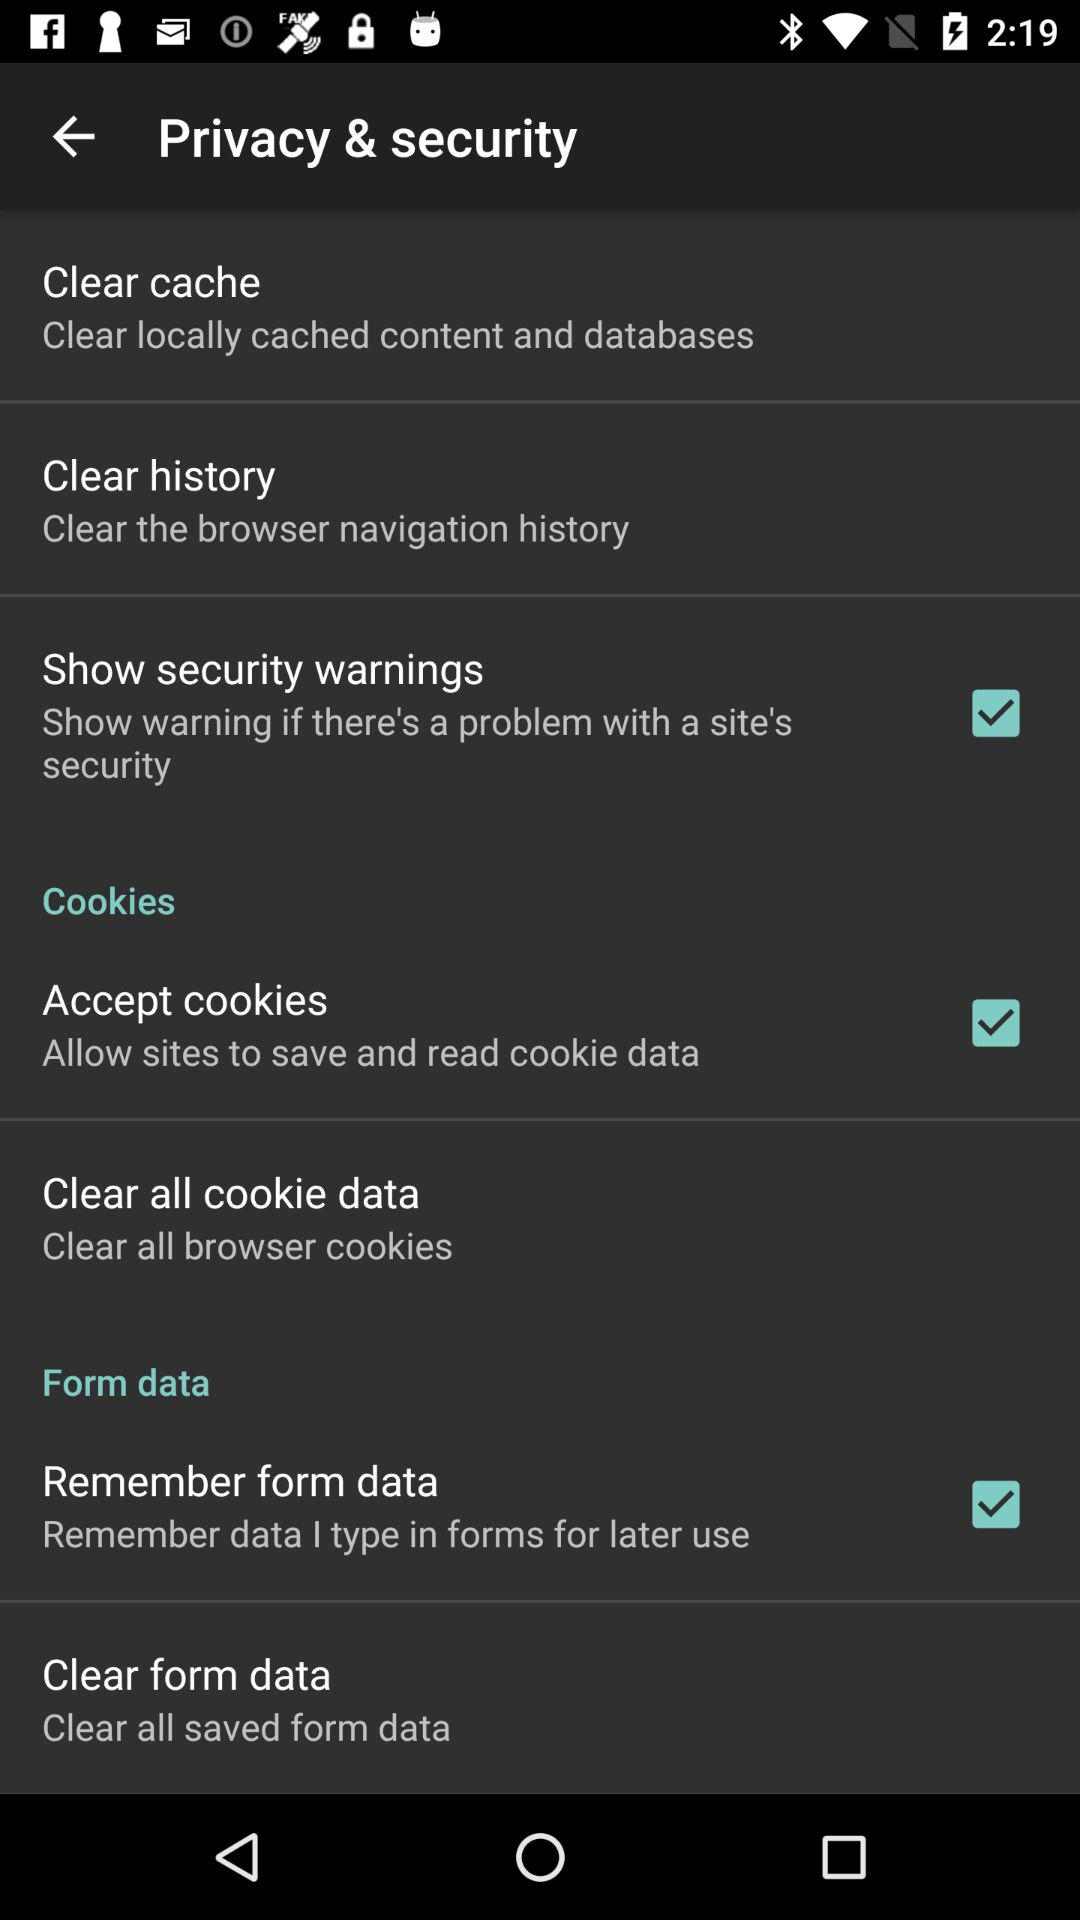What is the description of "Remember form data"? The description is "Remember data I type in forms for later use". 